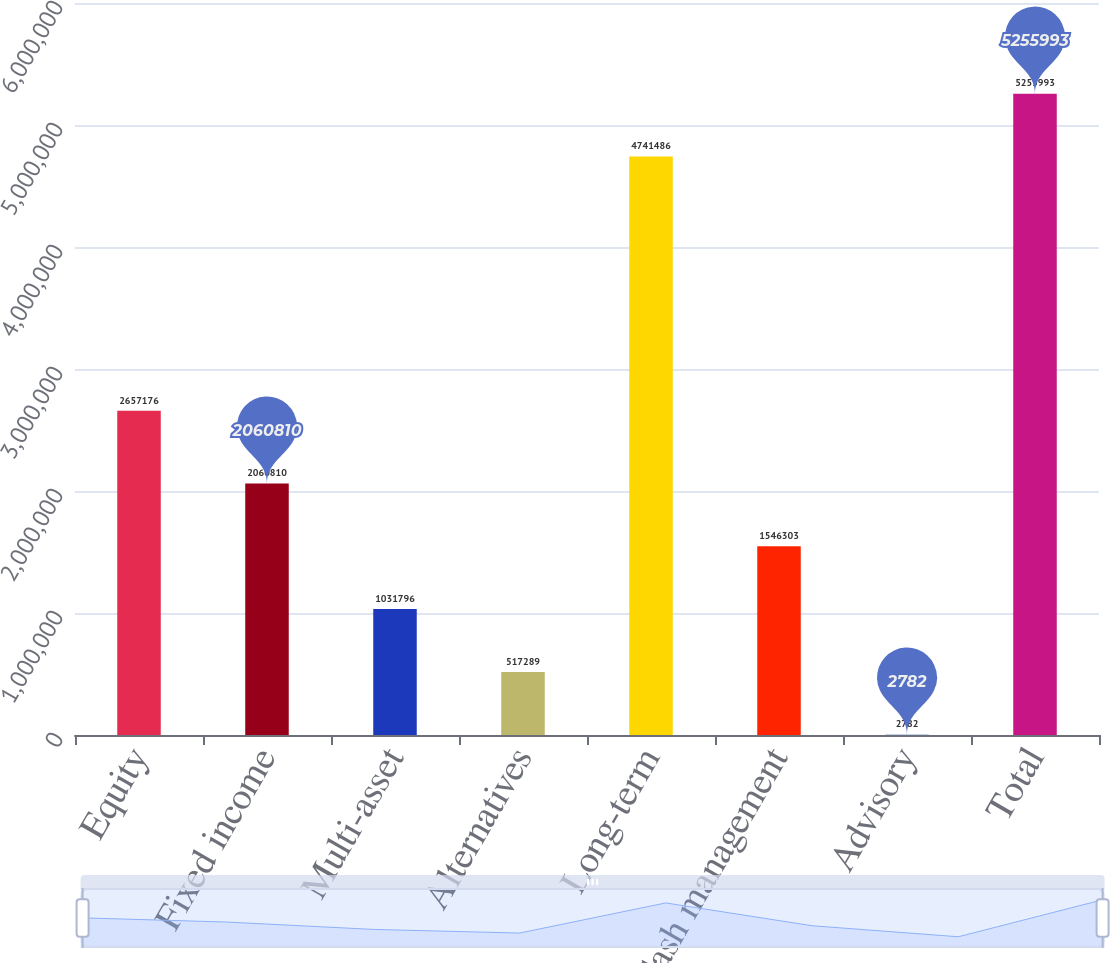Convert chart. <chart><loc_0><loc_0><loc_500><loc_500><bar_chart><fcel>Equity<fcel>Fixed income<fcel>Multi-asset<fcel>Alternatives<fcel>Long-term<fcel>Cash management<fcel>Advisory<fcel>Total<nl><fcel>2.65718e+06<fcel>2.06081e+06<fcel>1.0318e+06<fcel>517289<fcel>4.74149e+06<fcel>1.5463e+06<fcel>2782<fcel>5.25599e+06<nl></chart> 